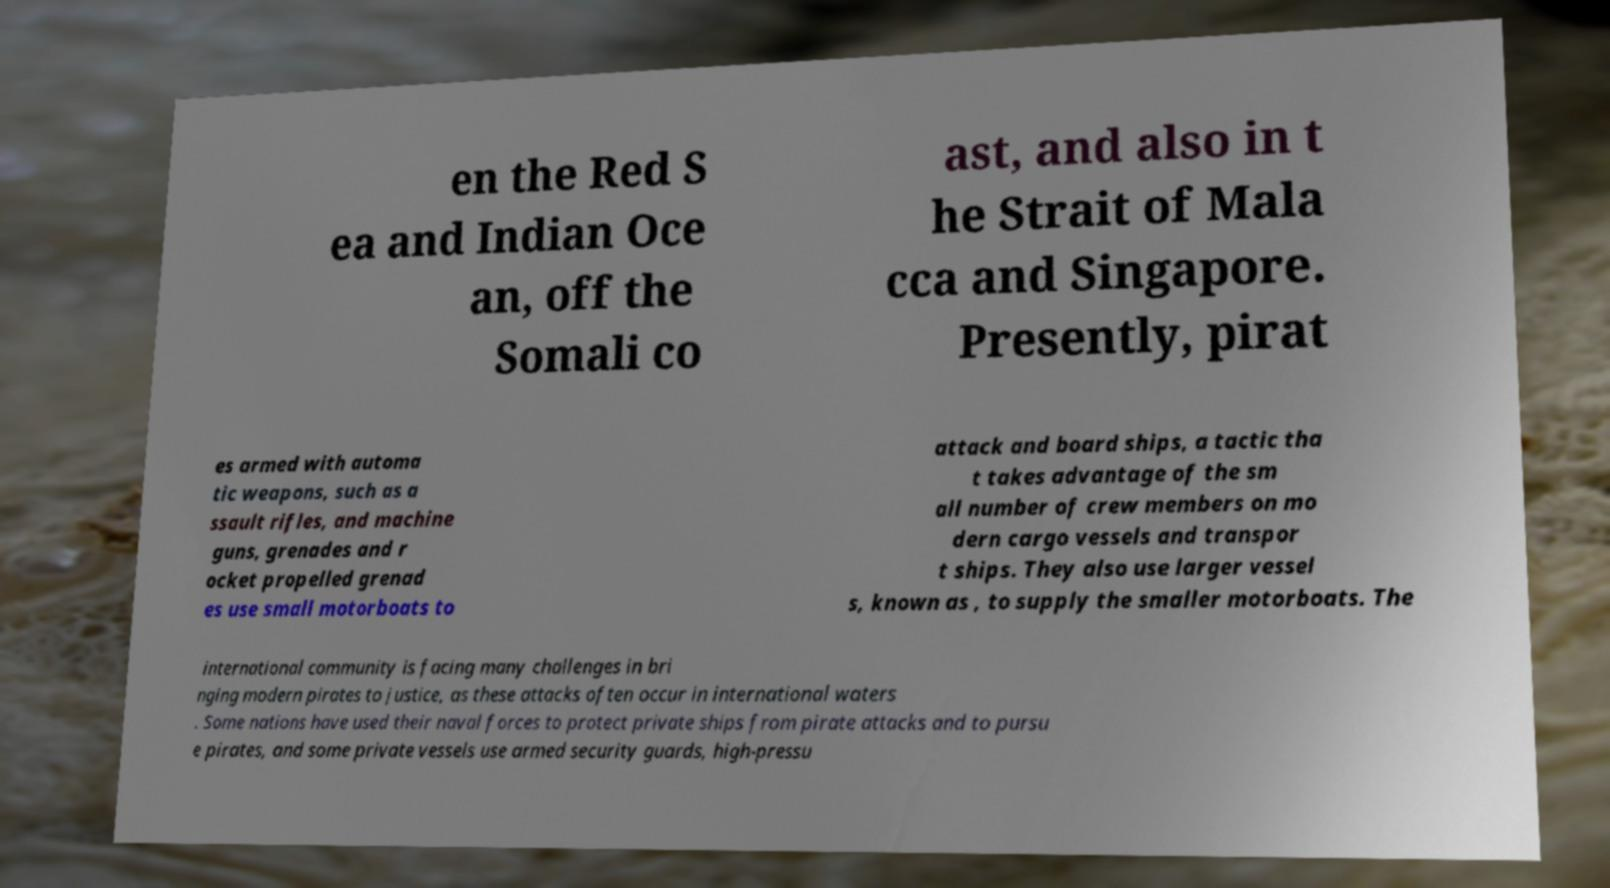Could you extract and type out the text from this image? en the Red S ea and Indian Oce an, off the Somali co ast, and also in t he Strait of Mala cca and Singapore. Presently, pirat es armed with automa tic weapons, such as a ssault rifles, and machine guns, grenades and r ocket propelled grenad es use small motorboats to attack and board ships, a tactic tha t takes advantage of the sm all number of crew members on mo dern cargo vessels and transpor t ships. They also use larger vessel s, known as , to supply the smaller motorboats. The international community is facing many challenges in bri nging modern pirates to justice, as these attacks often occur in international waters . Some nations have used their naval forces to protect private ships from pirate attacks and to pursu e pirates, and some private vessels use armed security guards, high-pressu 